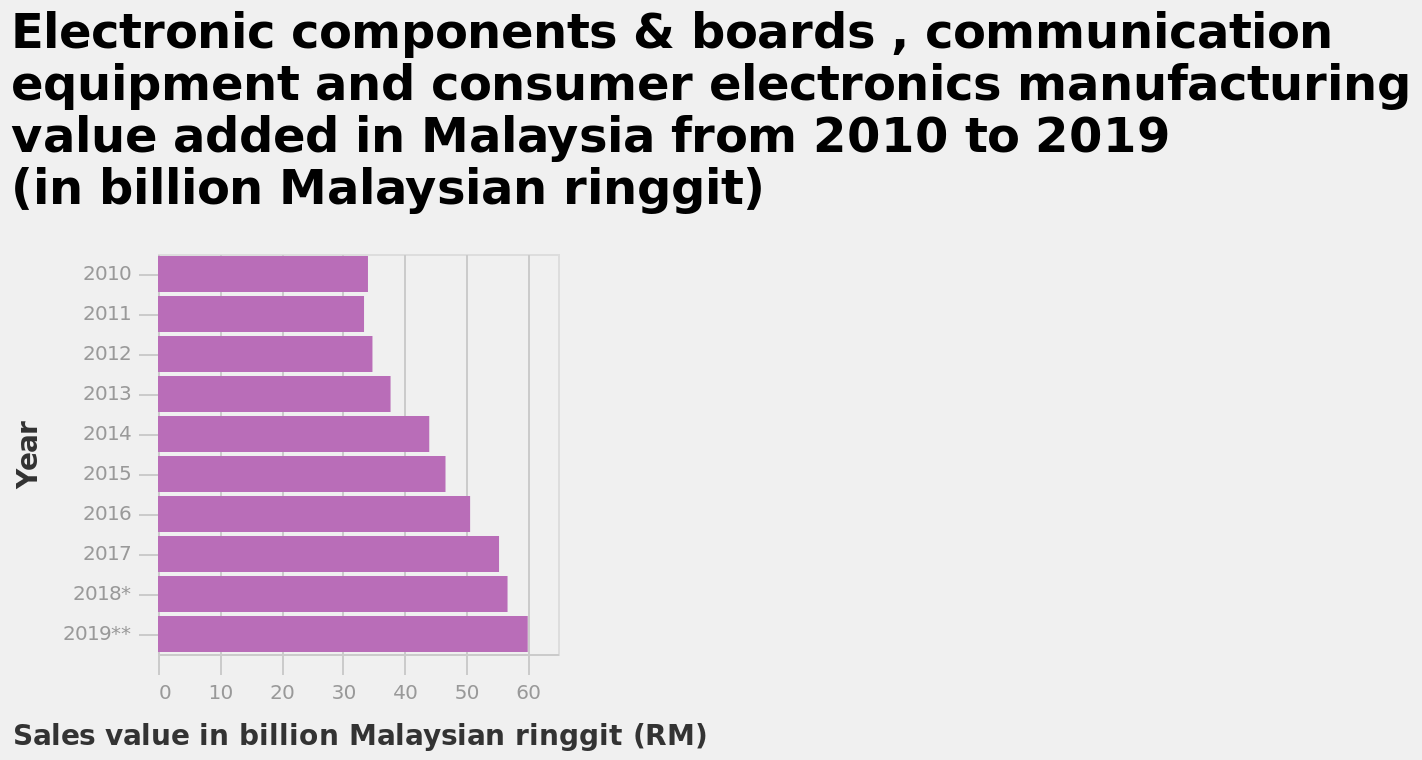<image>
Describe the following image in detail Here a bar graph is named Electronic components & boards , communication equipment and consumer electronics manufacturing value added in Malaysia from 2010 to 2019 (in billion Malaysian ringgit). Along the x-axis, Sales value in billion Malaysian ringgit (RM) is plotted. There is a categorical scale starting with 2010 and ending with 2019** along the y-axis, labeled Year. 